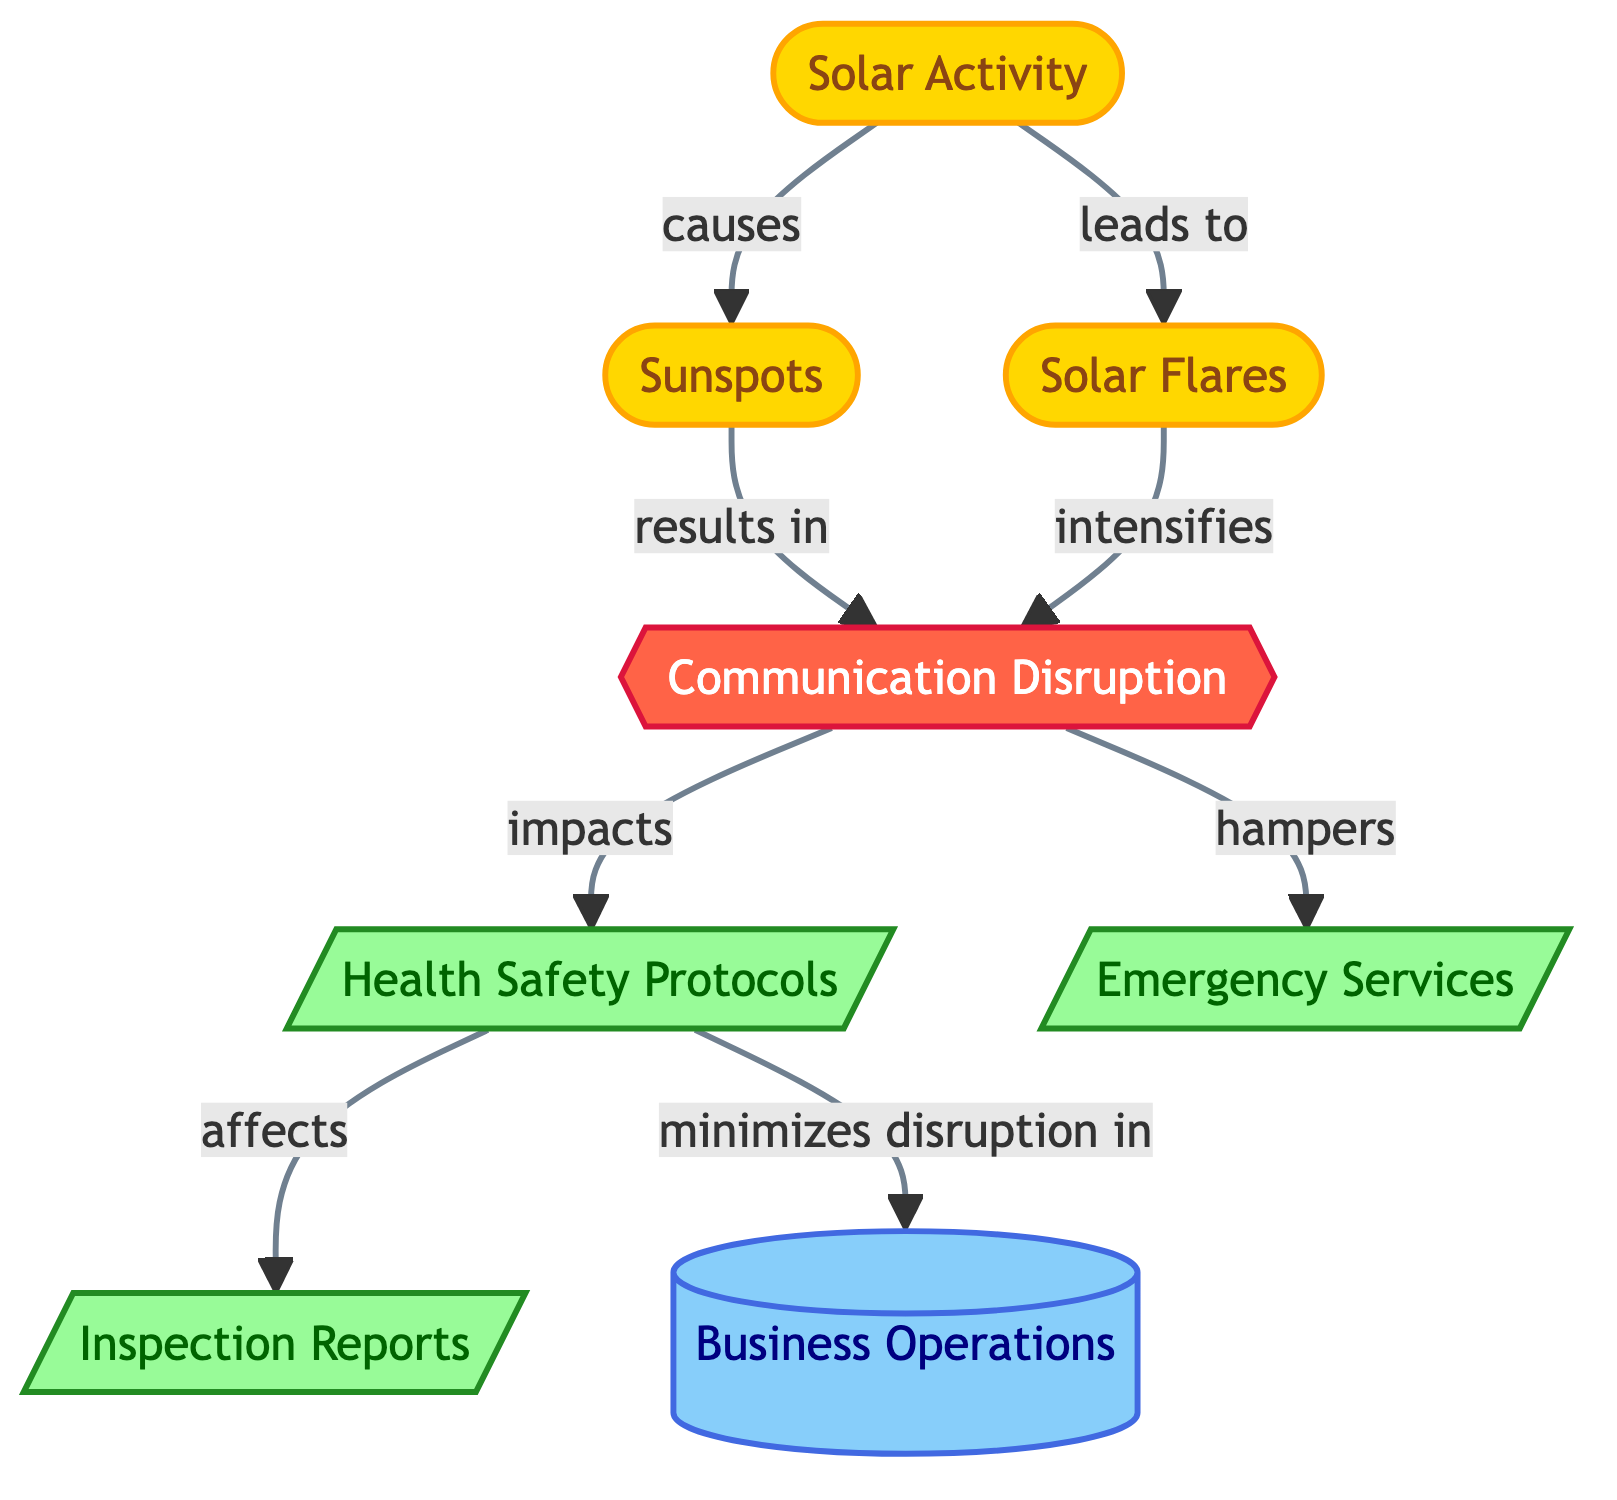What is the primary cause of Sunspots? According to the diagram, Sunspots are a result of Solar Activity. The arrow indicating the relationship shows that Solar Activity leads to the occurrence of Sunspots.
Answer: Solar Activity How many primary nodes are connected to Communication Disruption? The diagram shows that Communication Disruption is connected to three other nodes: Health Safety Protocols, Emergency Services, and is affected by both Sunspots and Solar Flares. Therefore, we count a total of three connections from Communication Disruption.
Answer: 3 What impacts Health Safety Protocols? The diagram indicates that Health Safety Protocols are impacted by Communication Disruption. It shows a direct connection from Communication Disruption to Health Safety Protocols, illustrating this influence.
Answer: Communication Disruption What does Health Safety Protocols minimize disruption in? The diagram clearly indicates that Health Safety Protocols work to minimize disruption in Business Operations. The arrow between these two nodes shows that the implementation of health protocols positively affects business operations in a crowded environment.
Answer: Business Operations Which two events lead to Communication Disruption? The diagram demonstrates that both Sunspots and Solar Flares lead to Communication Disruption. It illustrates how the effects of Solar Activity can manifest through these two events, influencing communication negatively.
Answer: Sunspots and Solar Flares How do Solar Flares influence Communication Disruption? Analysis of the diagram illustrates that Solar Flares intensify Communication Disruption. The relationship shown by the arrow indicates a direct effect where the increase in Solar Flares corresponds to an increase in communication issues.
Answer: Intensifies How do Emergency Services get affected? The diagram shows that Emergency Services are hampered by Communication Disruption. This indicates that any disruption in communication negatively impacts the effectiveness of emergency services.
Answer: Hampered What type of diagram is presented? The flowchart structure and the relationships depicted within it suggest that this is an Astronomy Diagram focused on Solar Activity Cycles and their influence on various sectors, specifically in health and communication protocols.
Answer: Astronomy Diagram 